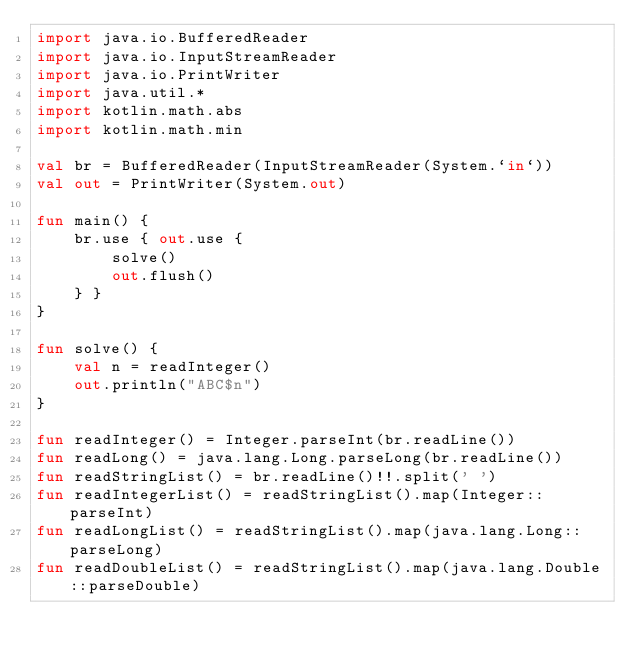Convert code to text. <code><loc_0><loc_0><loc_500><loc_500><_Kotlin_>import java.io.BufferedReader
import java.io.InputStreamReader
import java.io.PrintWriter
import java.util.*
import kotlin.math.abs
import kotlin.math.min

val br = BufferedReader(InputStreamReader(System.`in`))
val out = PrintWriter(System.out)

fun main() {
    br.use { out.use {
        solve()
        out.flush()
    } }
}

fun solve() {
    val n = readInteger()
    out.println("ABC$n")
}

fun readInteger() = Integer.parseInt(br.readLine())
fun readLong() = java.lang.Long.parseLong(br.readLine())
fun readStringList() = br.readLine()!!.split(' ')
fun readIntegerList() = readStringList().map(Integer::parseInt)
fun readLongList() = readStringList().map(java.lang.Long::parseLong)
fun readDoubleList() = readStringList().map(java.lang.Double::parseDouble)
</code> 